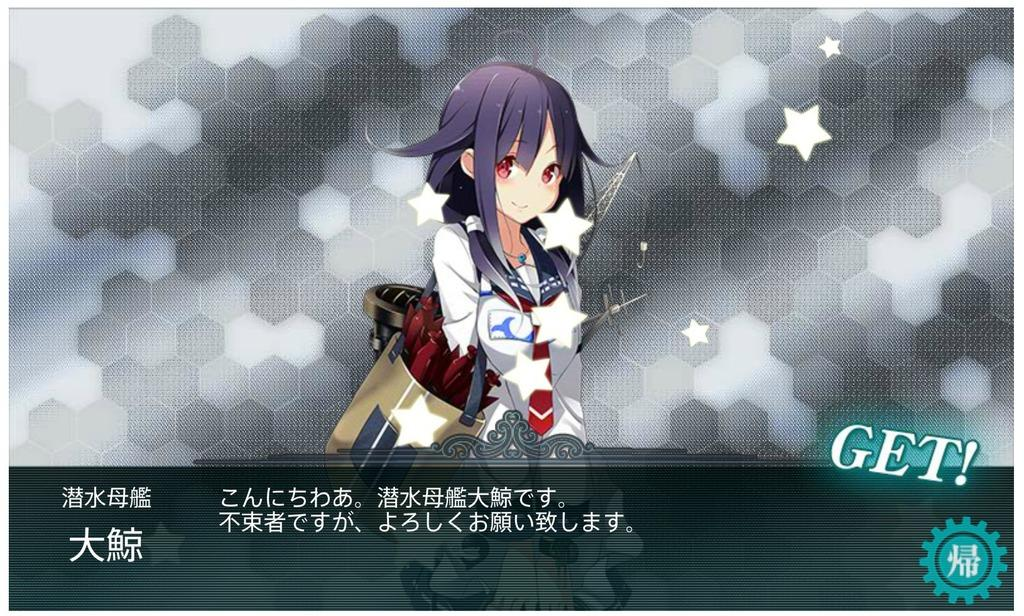What style is the image drawn in? The image is an anime depiction. Who is the main subject in the image? There is a girl in the image. What is the girl wearing? The girl is wearing a white dress. What is the girl holding in the image? The girl is holding a bag. What additional information is provided below the image? There is text below the image. What type of produce is the girl holding in the image? The girl is not holding any produce in the image; she is holding a bag. What committee is the girl a part of in the image? There is no committee mentioned or depicted in the image; it is an anime depiction of a girl holding a bag. 